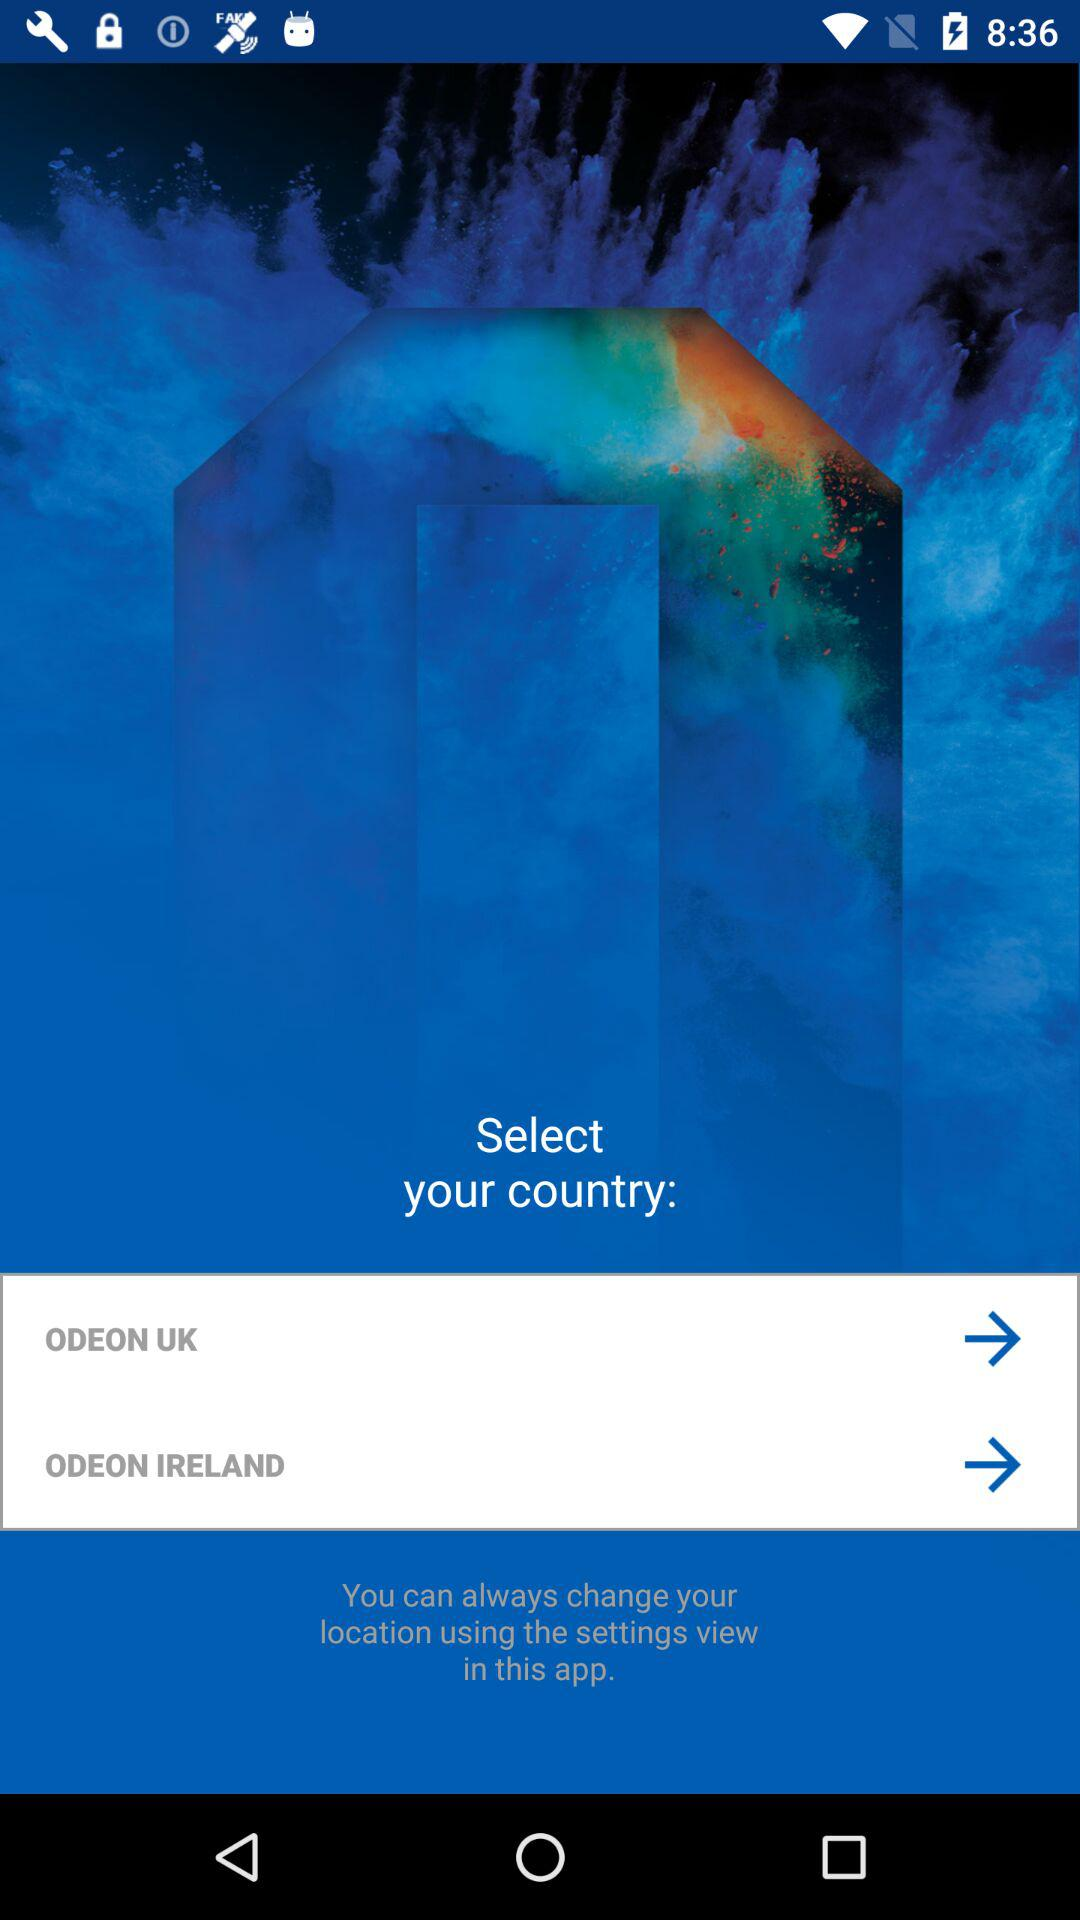How many countries are available to select?
Answer the question using a single word or phrase. 2 